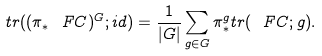<formula> <loc_0><loc_0><loc_500><loc_500>t r ( ( \pi _ { * } \ F C ) ^ { G } ; i d ) = \frac { 1 } { | G | } \sum _ { g \in G } \pi ^ { g } _ { * } t r ( \ F C ; g ) .</formula> 